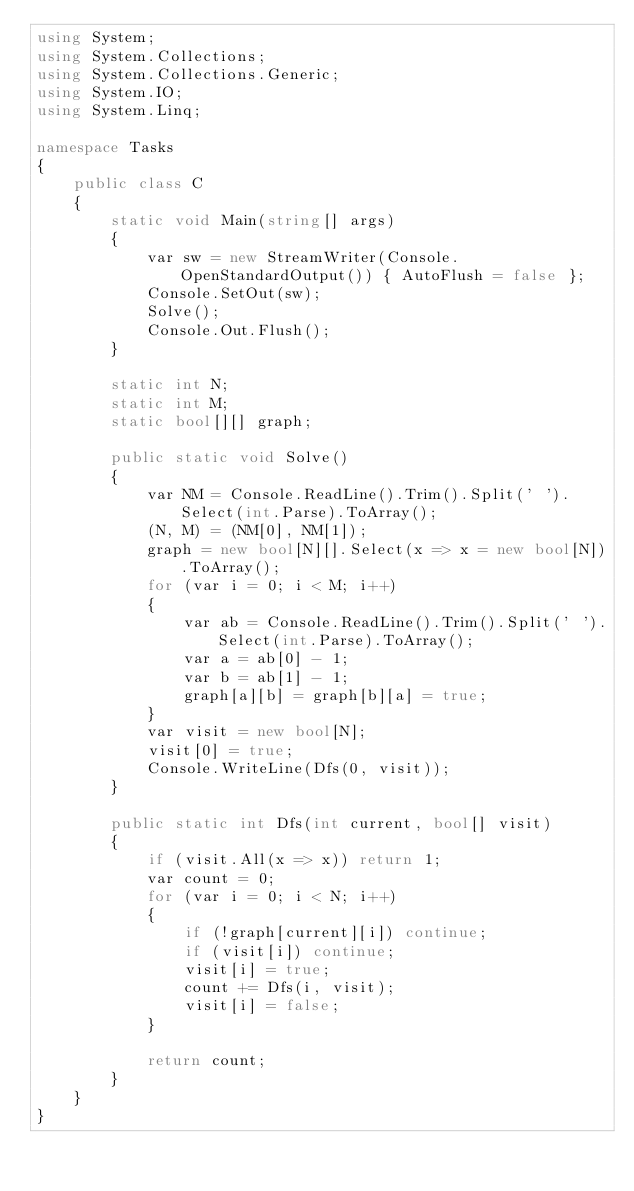Convert code to text. <code><loc_0><loc_0><loc_500><loc_500><_C#_>using System;
using System.Collections;
using System.Collections.Generic;
using System.IO;
using System.Linq;

namespace Tasks
{
    public class C
    {
        static void Main(string[] args)
        {
            var sw = new StreamWriter(Console.OpenStandardOutput()) { AutoFlush = false };
            Console.SetOut(sw);
            Solve();
            Console.Out.Flush();
        }

        static int N;
        static int M;
        static bool[][] graph;

        public static void Solve()
        {
            var NM = Console.ReadLine().Trim().Split(' ').Select(int.Parse).ToArray();
            (N, M) = (NM[0], NM[1]);
            graph = new bool[N][].Select(x => x = new bool[N]).ToArray();
            for (var i = 0; i < M; i++)
            {
                var ab = Console.ReadLine().Trim().Split(' ').Select(int.Parse).ToArray();
                var a = ab[0] - 1;
                var b = ab[1] - 1;
                graph[a][b] = graph[b][a] = true;
            }
            var visit = new bool[N];
            visit[0] = true;
            Console.WriteLine(Dfs(0, visit));
        }

        public static int Dfs(int current, bool[] visit)
        {
            if (visit.All(x => x)) return 1;
            var count = 0;
            for (var i = 0; i < N; i++)
            {
                if (!graph[current][i]) continue;
                if (visit[i]) continue;
                visit[i] = true;
                count += Dfs(i, visit);
                visit[i] = false;
            }

            return count;
        }
    }
}
</code> 